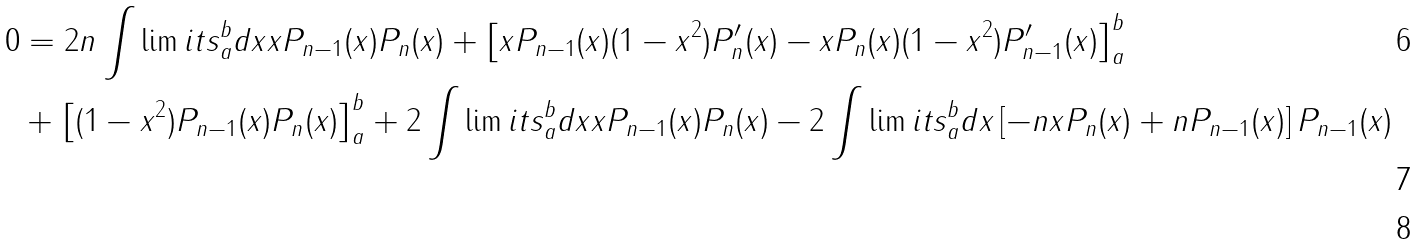<formula> <loc_0><loc_0><loc_500><loc_500>0 & = 2 n \int \lim i t s _ { a } ^ { b } d x x P _ { n - 1 } ( x ) P _ { n } ( x ) + \left [ x P _ { n - 1 } ( x ) ( 1 - x ^ { 2 } ) P ^ { \prime } _ { n } ( x ) - x P _ { n } ( x ) ( 1 - x ^ { 2 } ) P ^ { \prime } _ { n - 1 } ( x ) \right ] _ { a } ^ { b } \\ & + \left [ ( 1 - x ^ { 2 } ) P _ { n - 1 } ( x ) P _ { n } ( x ) \right ] _ { a } ^ { b } + 2 \int \lim i t s _ { a } ^ { b } d x x P _ { n - 1 } ( x ) P _ { n } ( x ) - 2 \int \lim i t s _ { a } ^ { b } d x \left [ - n x P _ { n } ( x ) + n P _ { n - 1 } ( x ) \right ] P _ { n - 1 } ( x ) \\</formula> 